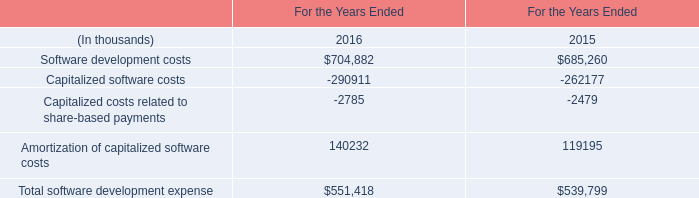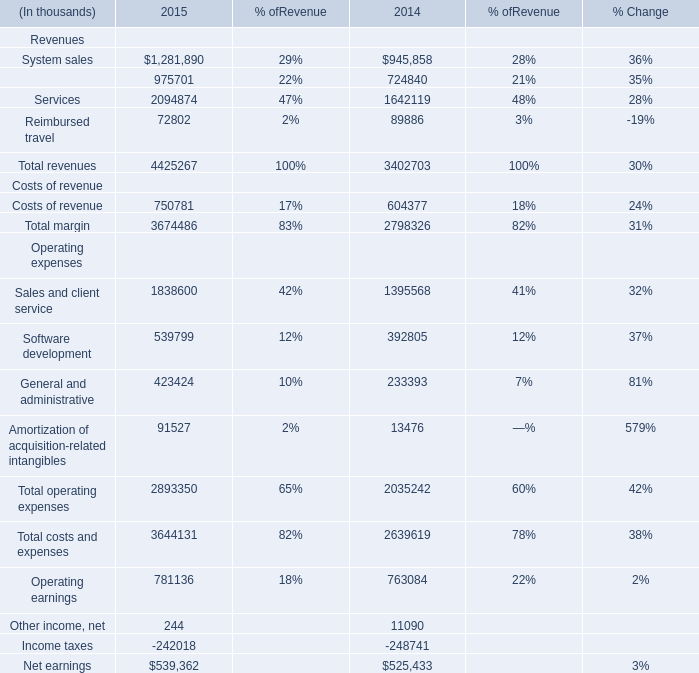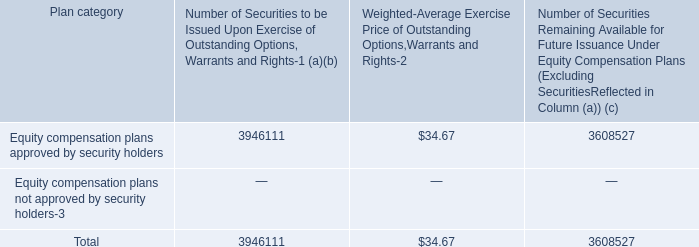What is the sum of Reimbursed travel of 2014, Software development costs of For the Years Ended 2016, and Total costs and expenses Operating expenses of 2014 ? 
Computations: ((89886.0 + 704882.0) + 2639619.0)
Answer: 3434387.0. 